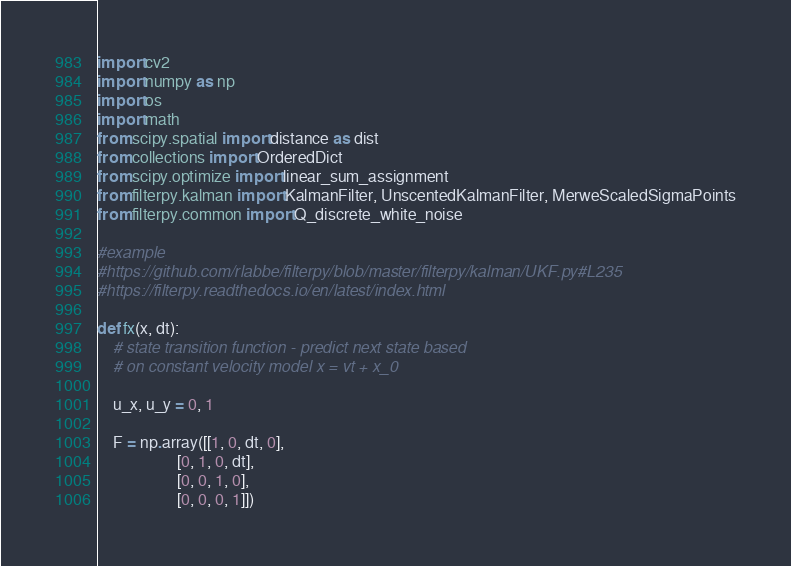<code> <loc_0><loc_0><loc_500><loc_500><_Python_>import cv2
import numpy as np
import os
import math
from scipy.spatial import distance as dist
from collections import OrderedDict
from scipy.optimize import linear_sum_assignment
from filterpy.kalman import KalmanFilter, UnscentedKalmanFilter, MerweScaledSigmaPoints
from filterpy.common import Q_discrete_white_noise

#example
#https://github.com/rlabbe/filterpy/blob/master/filterpy/kalman/UKF.py#L235
#https://filterpy.readthedocs.io/en/latest/index.html

def fx(x, dt):
    # state transition function - predict next state based
    # on constant velocity model x = vt + x_0

    u_x, u_y = 0, 1

    F = np.array([[1, 0, dt, 0],
                    [0, 1, 0, dt],
                    [0, 0, 1, 0],
                    [0, 0, 0, 1]])
</code> 